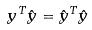Convert formula to latex. <formula><loc_0><loc_0><loc_500><loc_500>y ^ { T } \hat { y } = \hat { y } ^ { T } \hat { y }</formula> 